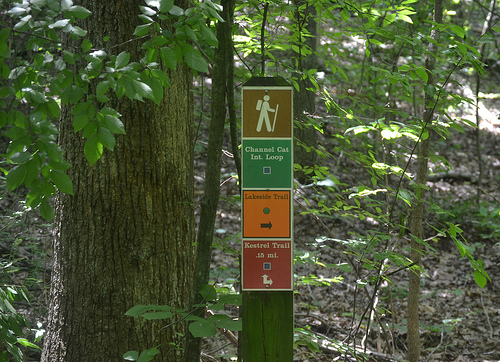<image>
Is there a sign behind the tree? No. The sign is not behind the tree. From this viewpoint, the sign appears to be positioned elsewhere in the scene. 